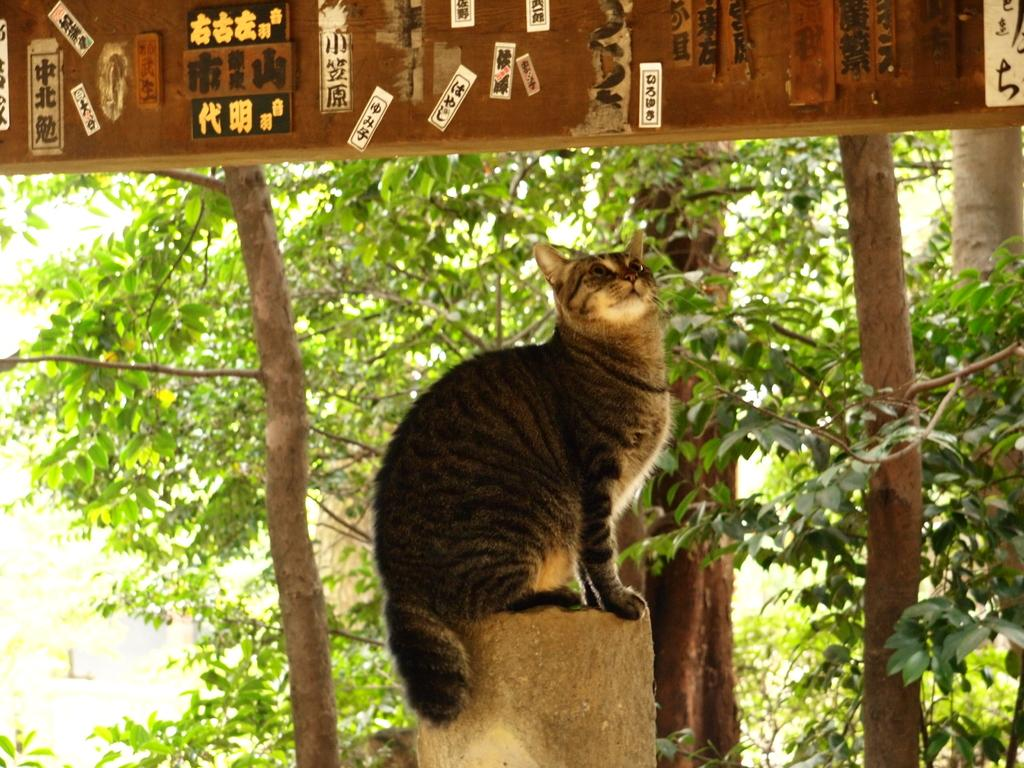What animal can be seen on a platform in the image? There is a cat on a platform in the image. What is the cat standing on in the image? The cat is standing on a platform. What can be seen on the wooden board in the image? There are posts on a wooden board in the image. What type of natural scenery is visible in the background of the image? There are trees visible in the background of the image. How does the cat care for its territory in the image? The image does not show the cat caring for its territory; it only shows the cat standing on a platform. 